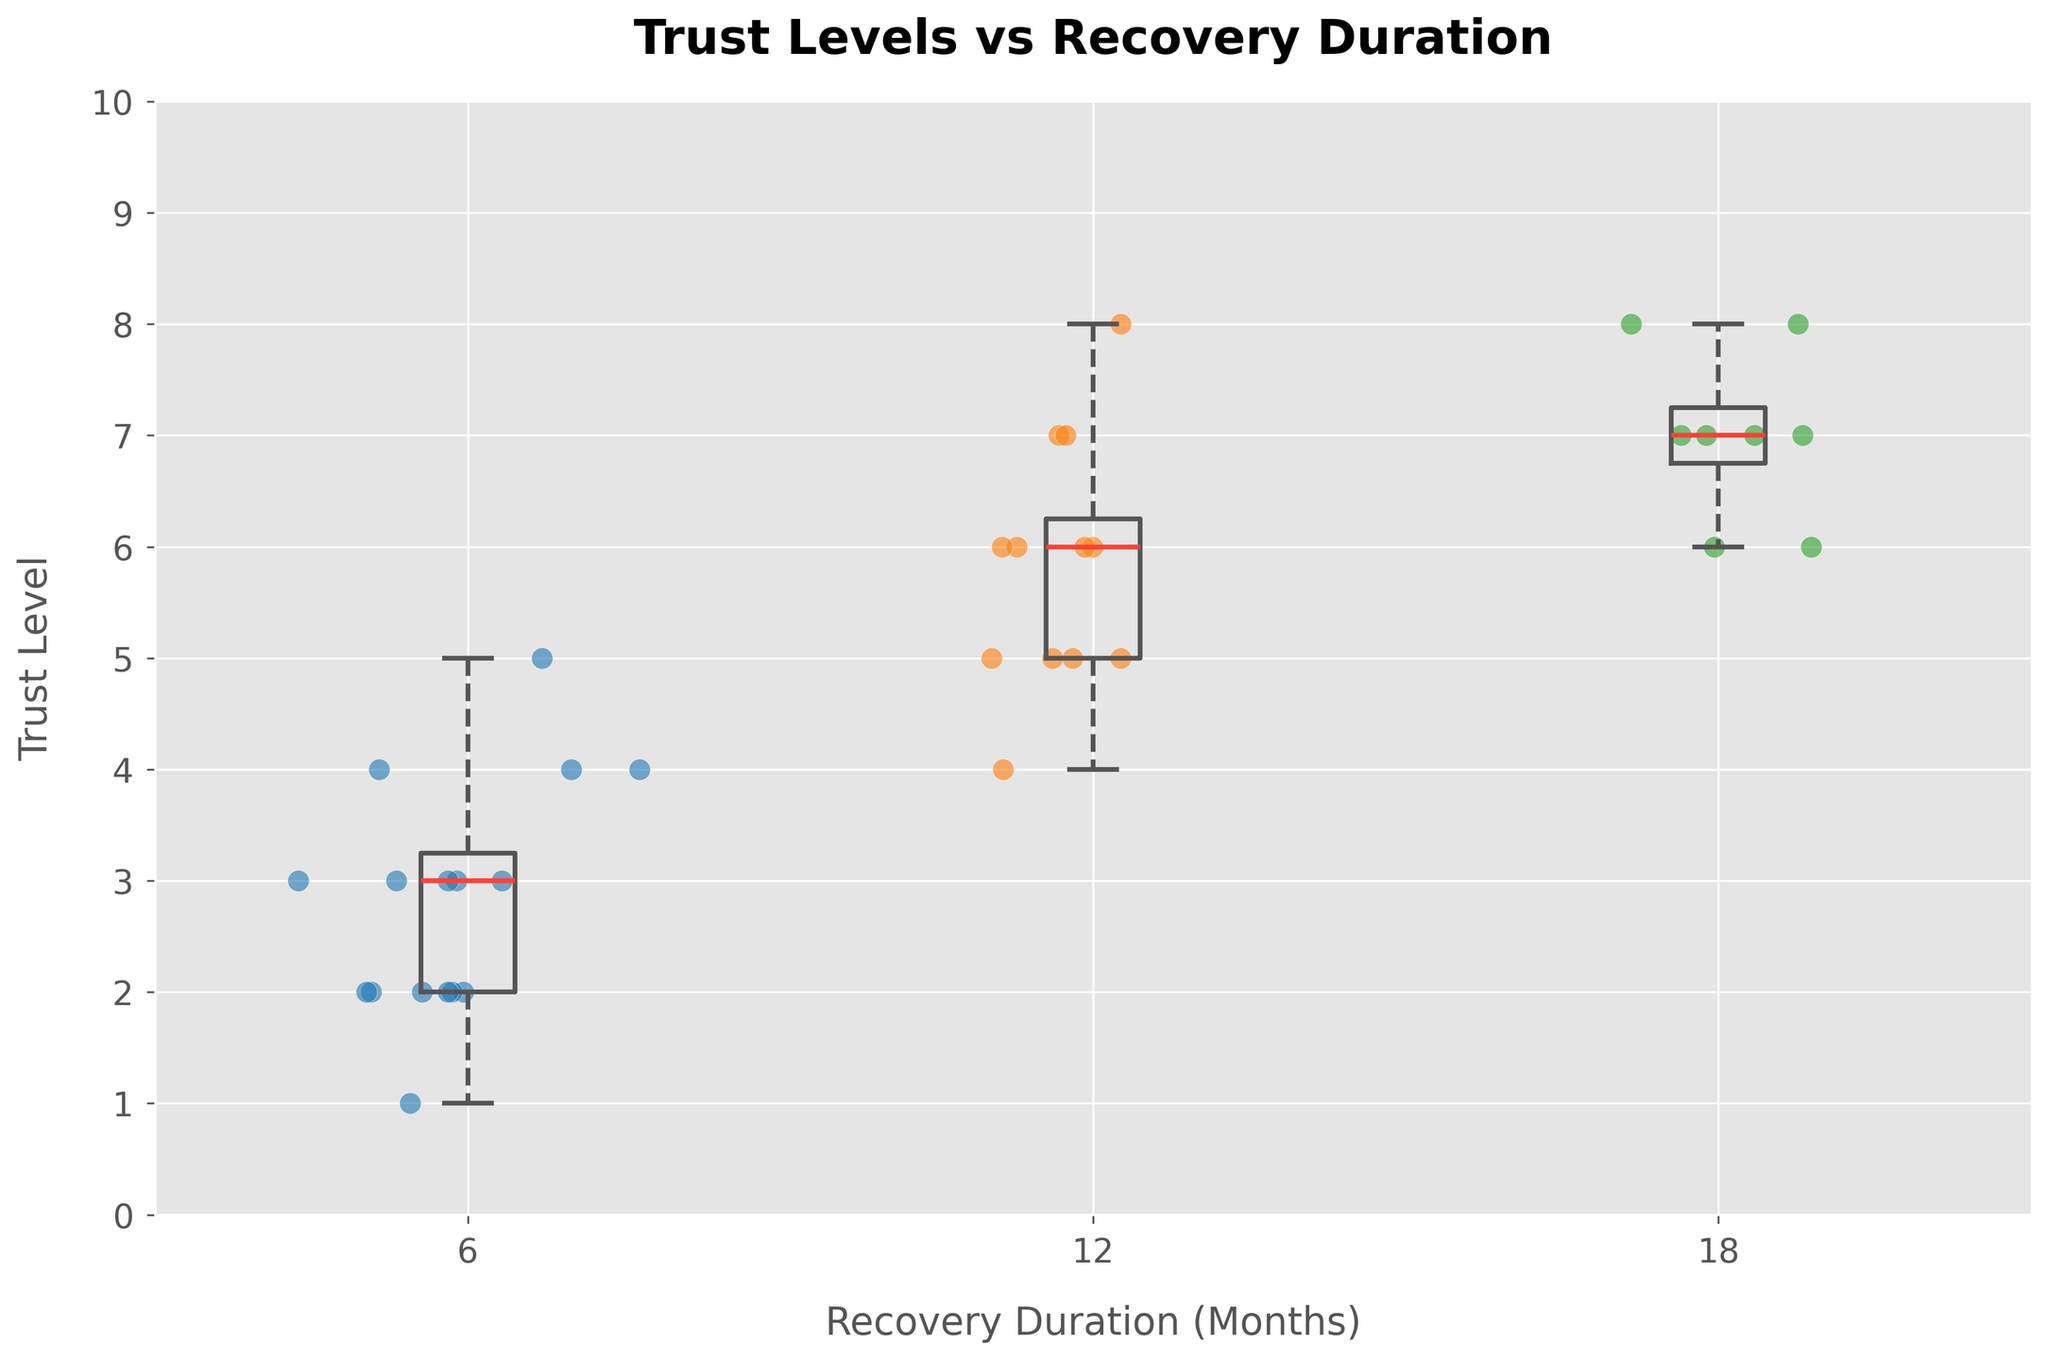What is the title of the plot? The title of the plot is typically displayed at the top in bold and large font size. In this case, it reads "Trust Levels vs Recovery Duration".
Answer: Trust Levels vs Recovery Duration Which axis displays the recovery duration? The x-axis usually displays categorical or independent variables. In this plot, the x-axis is labeled "Recovery Duration (Months)" and shows three different values: 6, 12, and 18 months.
Answer: x-axis How is trust level visually represented in this plot? Trust levels are represented by both box plots and scatter points along the y-axis. The y-axis is labeled "Trust Level". The box plots show distributions, while scatter points represent individual data entries.
Answer: Box plots and scatter points What is the median trust level for a recovery duration of 12 months? To find the median trust level, locate the central line inside the box plot corresponding to the 12-month recovery duration on the x-axis. The median is marked by a line through the middle of the box.
Answer: 6 Which recovery duration shows the highest median trust level? Compare the median lines (middle lines of the boxes) across the different recovery durations (6, 12, and 18 months). The box corresponding to the recovery duration of 18 months has the highest median line.
Answer: 18 months What is the range of trust levels for a recovery duration of 6 months? The range can be found by looking at the lowest and highest points of the box plot's whiskers for the 6-month duration. The whiskers extend from the minimum to the maximum data points, excluding outliers.
Answer: 1 to 5 How does the distribution of trust levels differ between 6 months and 18 months? Compare the box plots and scatter points for both durations. For 6 months, data points and the box plot are more compressed, indicating a lower trust level range (1-5). For 18 months, the box plot is higher and the data points are spread out more (6-8).
Answer: Trust levels are lower and compressed at 6 months; higher and more spread out at 18 months What's the difference between the maximum trust level at 6 months and the maximum trust level at 18 months? Identify the maximum trust levels from the whiskers for both durations. The maximum trust level at 6 months is 5, while at 18 months it is 8. Subtract the two values to get the difference.
Answer: 3 How do the scatter points complement the box plots in this figure? The scatter points provide individual data point details that may not be clear in the box plots. They show the exact distribution of trust levels within each recovery duration, highlighting outliers and the overall spread.
Answer: Highlight individual data points and distribution Do all participants have equal distributions of trust levels across different recovery durations? Observe the scatter plots for each recovery duration to determine if data points are evenly distributed. Some recovery durations may have more spread or concentrated points, indicating uneven distributions.
Answer: No 